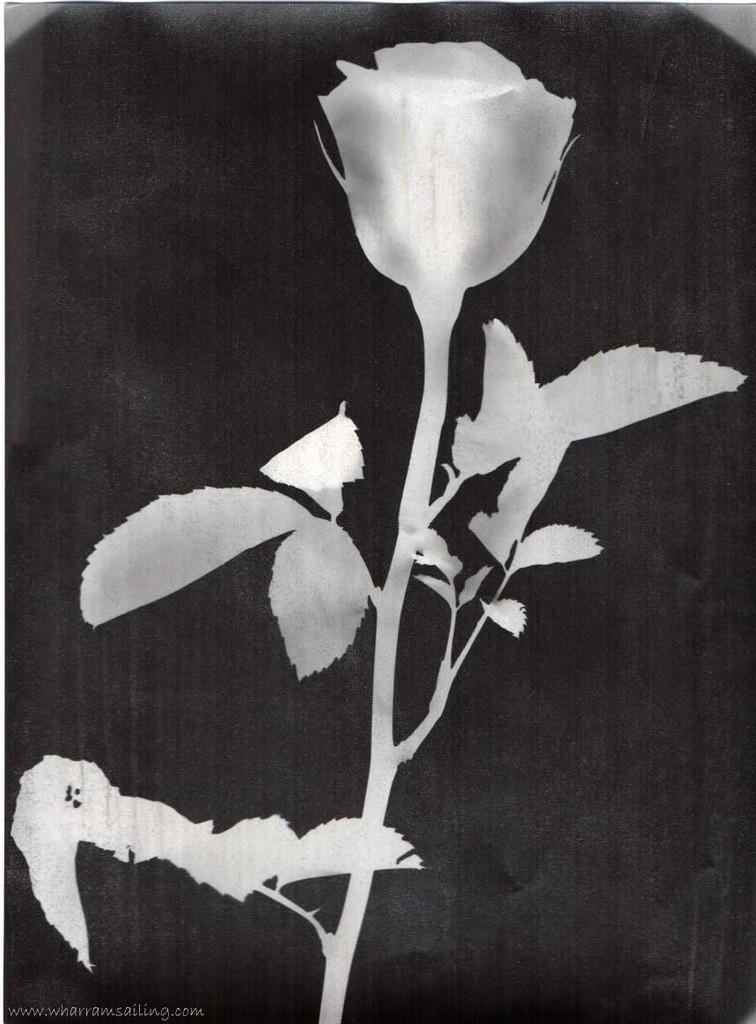What is the color scheme of the image? The image is black and white. What type of flower can be seen in the image? There is a rose flower in the image. What else is present in the image besides the rose flower? There are leaves in the image. What language is spoken by the rose flower in the image? Roses do not speak any language, so there is no language spoken by the rose flower in the image. 